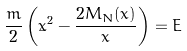<formula> <loc_0><loc_0><loc_500><loc_500>\frac { m } { 2 } \left ( \dot { x } ^ { 2 } - \frac { 2 M _ { N } ( x ) } { x } \right ) = E</formula> 